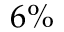Convert formula to latex. <formula><loc_0><loc_0><loc_500><loc_500>6 \%</formula> 